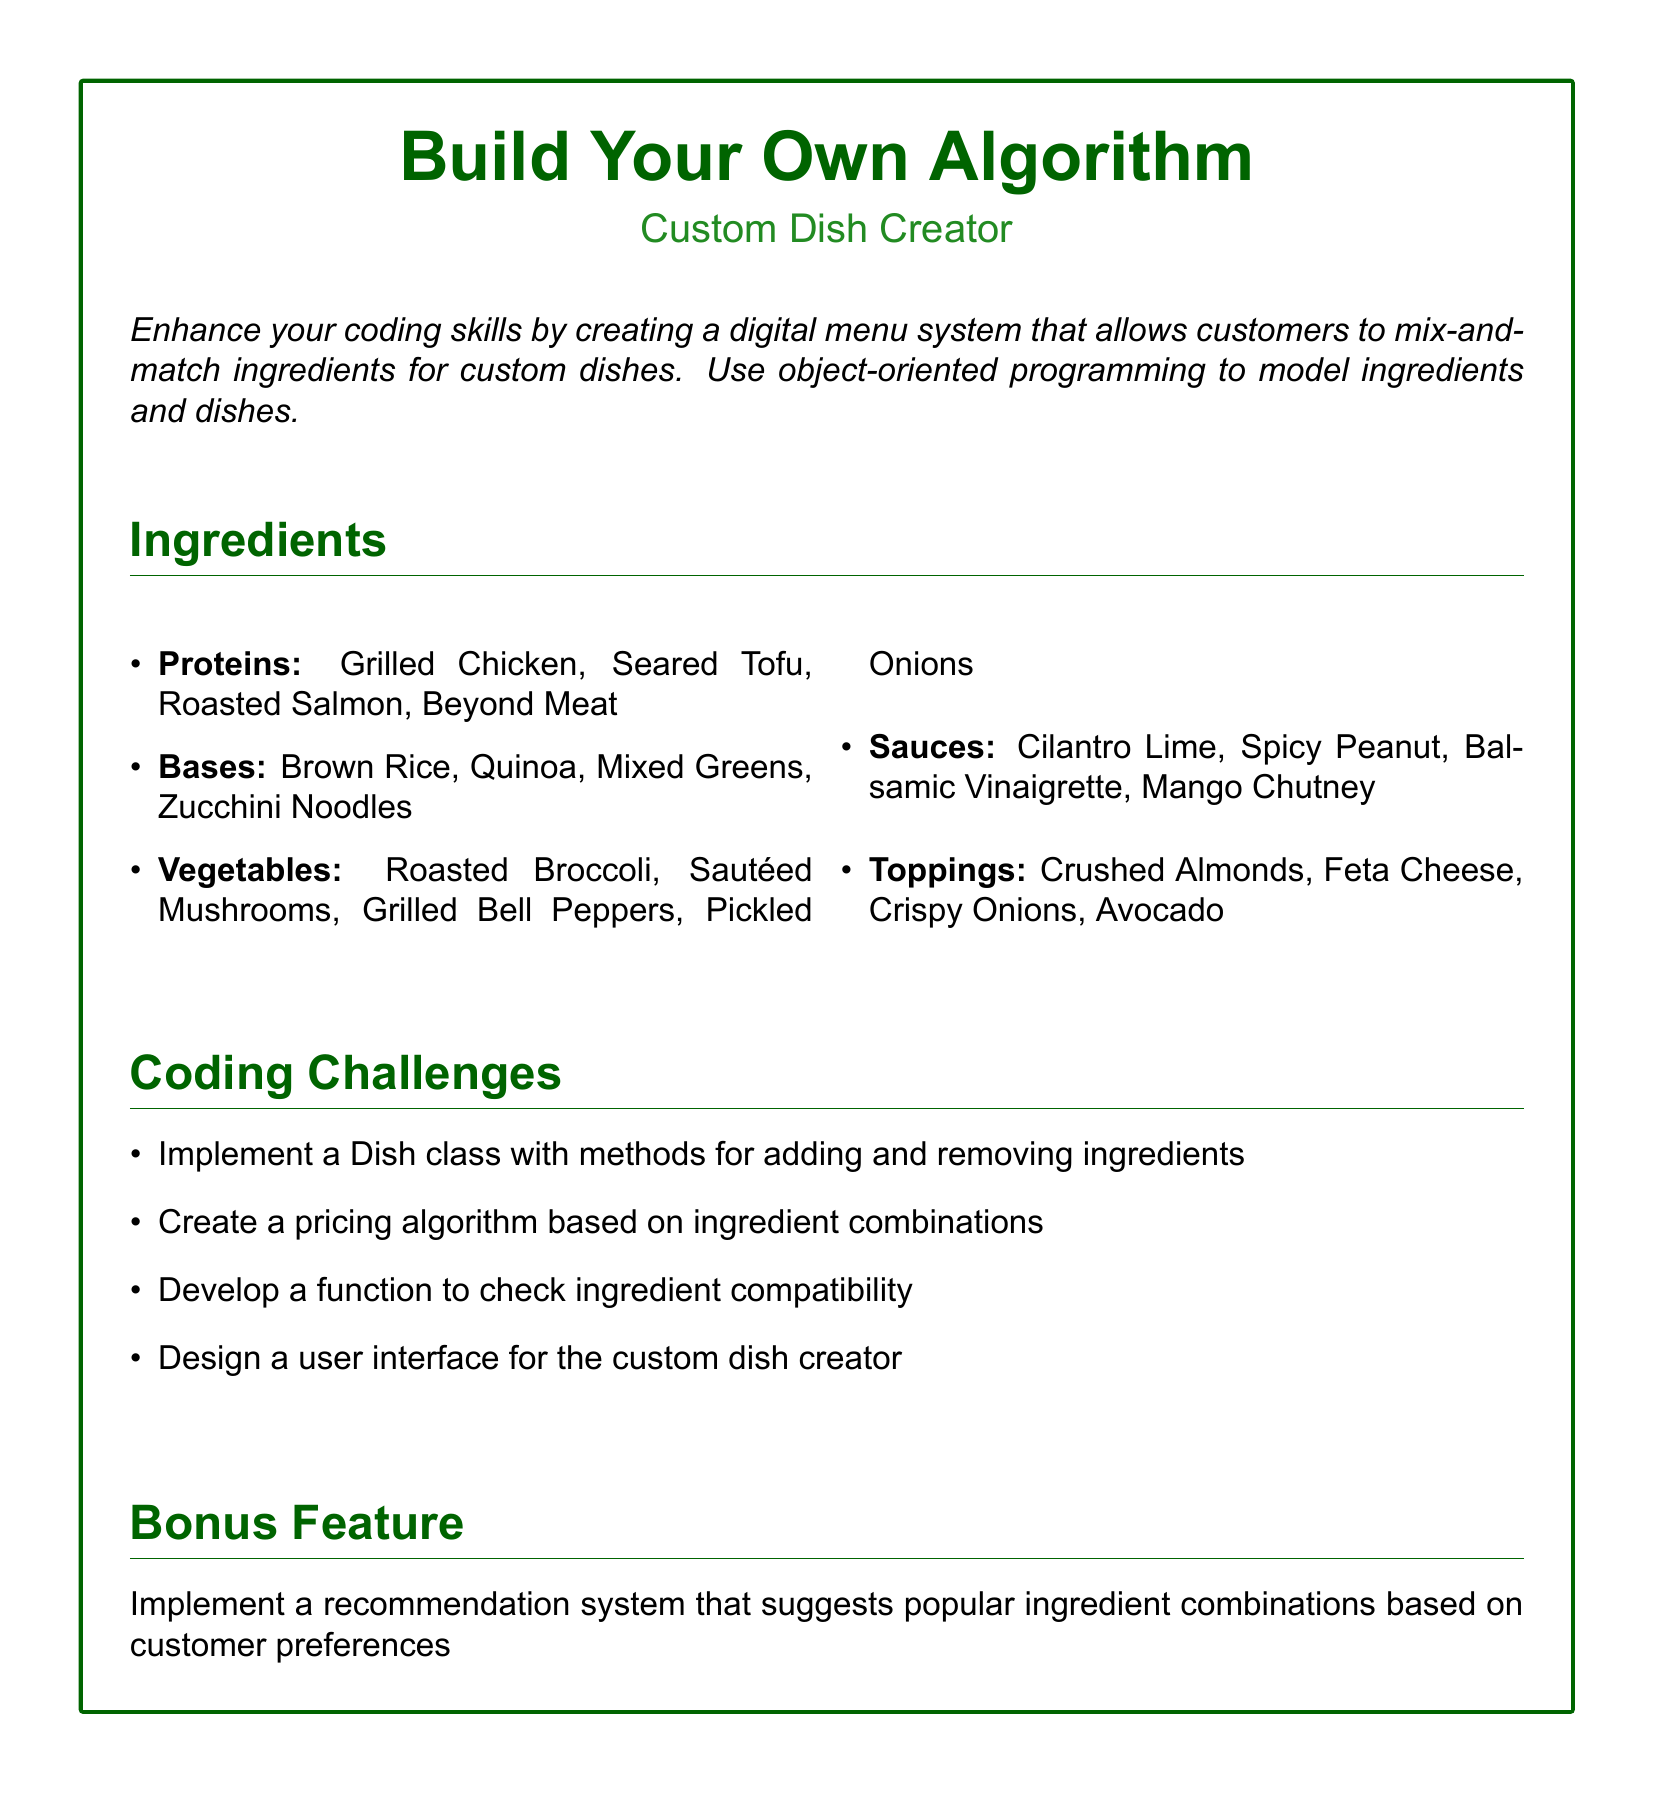what is the title of the section? The title of the section is indicated in a large font at the top of the box, highlighting the main focus of the menu.
Answer: Build Your Own Algorithm how many categories of ingredients are listed? The document explicitly categorizes the ingredients into five specific types.
Answer: Five which protein ingredient is plant-based? The document specifies which protein options meet the criteria of being derived from plants.
Answer: Seared Tofu name one type of sauce offered. A selection of sauces is provided, with a focus on variety and flavor.
Answer: Cilantro Lime what is the bonus feature mentioned? The bonus feature is an additional functionality that enhances customer interaction with the menu.
Answer: Recommendation system what is one of the coding challenges? The document outlines tasks designed to improve the programming skills related to the dish creation system.
Answer: Pricing algorithm how many topping options are provided? The menu lists a selection of topping options available for customization of dishes.
Answer: Four which ingredient can be used as a base? The document clearly distinguishes different types of bases used for the custom dishes.
Answer: Brown Rice what is the font used in the document? The typeface for the entire document is specified to ensure consistency in presentation.
Answer: Arial 